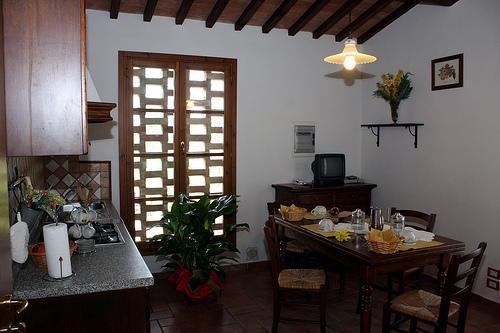How many chairs are there?
Give a very brief answer. 4. How many pictures are hanging on the wall?
Give a very brief answer. 1. 